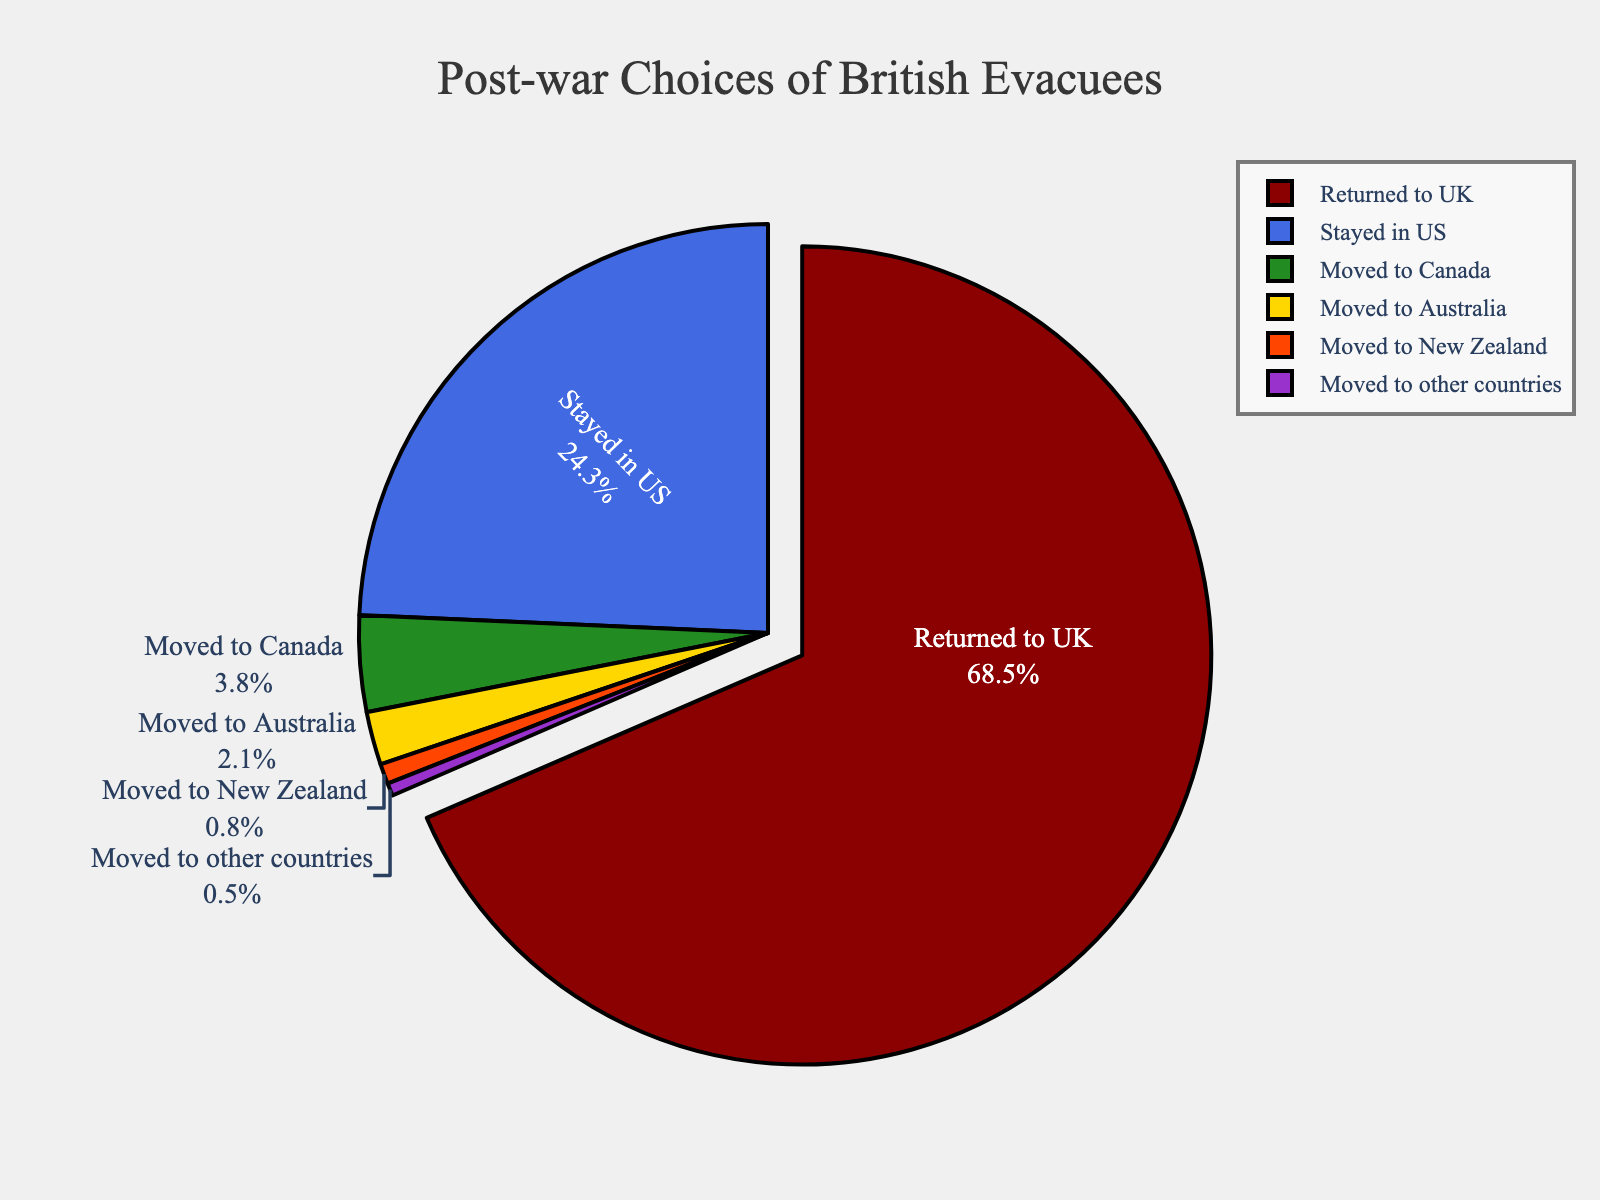What's the percentage of evacuees who either stayed in the US or moved to Canada? First, find the percentages of the two categories: staying in the US is 24.3% and moving to Canada is 3.8%. Then, add these two percentages together: 24.3% + 3.8% = 28.1%.
Answer: 28.1% Which category had the smallest percentage of evacuees? By examining the chart, the category with the smallest percentage is "Moved to other countries" with 0.5%.
Answer: Moved to other countries Are there more evacuees who moved to New Zealand or to Australia? From the chart, the percentage of evacuees who moved to New Zealand is 0.8%, and those who moved to Australia is 2.1%. Comparing these two, 2.1% is greater than 0.8%.
Answer: Australia What is the difference in percentages between those who returned to the UK and those who stayed in the US? The percentage of evacuees who returned to the UK is 68.5% and those who stayed in the US is 24.3%. Subtracting the smaller percentage from the larger gives: 68.5% - 24.3% = 44.2%.
Answer: 44.2% What percentage of evacuees moved to locations other than the UK or the US? First identify the percentage of evacuees that returned to the UK (68.5%) and stayed in the US (24.3%). The total percentage for these groups is 68.5% + 24.3% = 92.8%. Thus, the percentage of evacuees who moved elsewhere is 100% - 92.8% = 7.2%.
Answer: 7.2% How much larger is the percentage of evacuees returning to the UK compared to those moving to Canada, Australia, New Zealand, and other countries combined? The total percentages for moving to Canada, Australia, New Zealand, and other countries are 3.8% + 2.1% + 0.8% + 0.5% = 7.2%. The percentage for those returning to the UK is 68.5%. The difference is 68.5% - 7.2% = 61.3%.
Answer: 61.3% What are the two largest categories of post-war choices made by British evacuees? By examining the chart, the two largest categories are "Returned to UK" with 68.5% and "Stayed in US" with 24.3%.
Answer: Returned to UK, Stayed in US Which segment in the pie chart is pulled out slightly from the rest, and why? The segment "Returned to UK" is pulled out slightly to emphasize that it has the largest percentage (68.5%) compared to other categories.
Answer: Returned to UK 